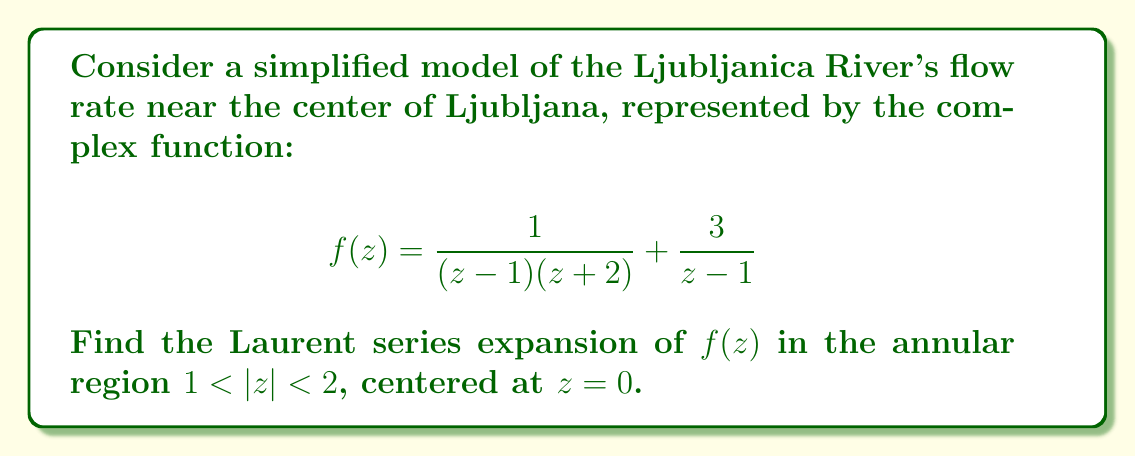Give your solution to this math problem. To find the Laurent series expansion of $f(z)$ in the annular region $1 < |z| < 2$, we'll follow these steps:

1) First, let's decompose $f(z)$ into partial fractions:

   $$f(z) = \frac{1}{(z-1)(z+2)} + \frac{3}{z-1} = \frac{A}{z-1} + \frac{B}{z+2} + \frac{3}{z-1}$$

   where $A$ and $B$ are constants to be determined.

2) Solving for $A$ and $B$:
   
   $$1 = A(z+2) + B(z-1)$$
   
   When $z = 1$: $1 = 3A$, so $A = \frac{1}{3}$
   When $z = -2$: $1 = -3B$, so $B = -\frac{1}{3}$

3) Therefore, our function can be written as:

   $$f(z) = \frac{1/3}{z-1} - \frac{1/3}{z+2} + \frac{3}{z-1} = \frac{10/3}{z-1} - \frac{1/3}{z+2}$$

4) Now, we need to expand each term in a Laurent series:

   For $\frac{10/3}{z-1}$:
   $$\frac{10/3}{z-1} = -\frac{10/3}{1-z} = -\frac{10}{3}(1 + z + z^2 + z^3 + ...)$$
   This is valid for $|z| < 1$, but we're in the region $1 < |z| < 2$, so we need:
   $$\frac{10/3}{z-1} = \frac{10/3}{z}\cdot\frac{1}{1-\frac{1}{z}} = \frac{10}{3z}(1 + \frac{1}{z} + \frac{1}{z^2} + ...)$$

   For $-\frac{1/3}{z+2}$:
   $$-\frac{1/3}{z+2} = -\frac{1/3}{z}\cdot\frac{1}{1+\frac{2}{z}} = -\frac{1}{3z}(1 - \frac{2}{z} + \frac{4}{z^2} - \frac{8}{z^3} + ...)$$

5) Combining these series:

   $$f(z) = (\frac{10}{3z} + \frac{10}{3z^2} + \frac{10}{3z^3} + ...) + (-\frac{1}{3z} + \frac{2}{3z^2} - \frac{4}{3z^3} + ...)$$

6) Collecting like terms:

   $$f(z) = 3z^{-1} + 4z^{-2} + 2z^{-3} + \frac{10}{3}z^{-4} + \frac{10}{3}z^{-5} + ...$$

This is the Laurent series expansion of $f(z)$ in the annular region $1 < |z| < 2$, centered at $z=0$.
Answer: The Laurent series expansion of $f(z)$ in $1 < |z| < 2$, centered at $z=0$, is:

$$f(z) = 3z^{-1} + 4z^{-2} + 2z^{-3} + \frac{10}{3}z^{-4} + \frac{10}{3}z^{-5} + ...$$ 